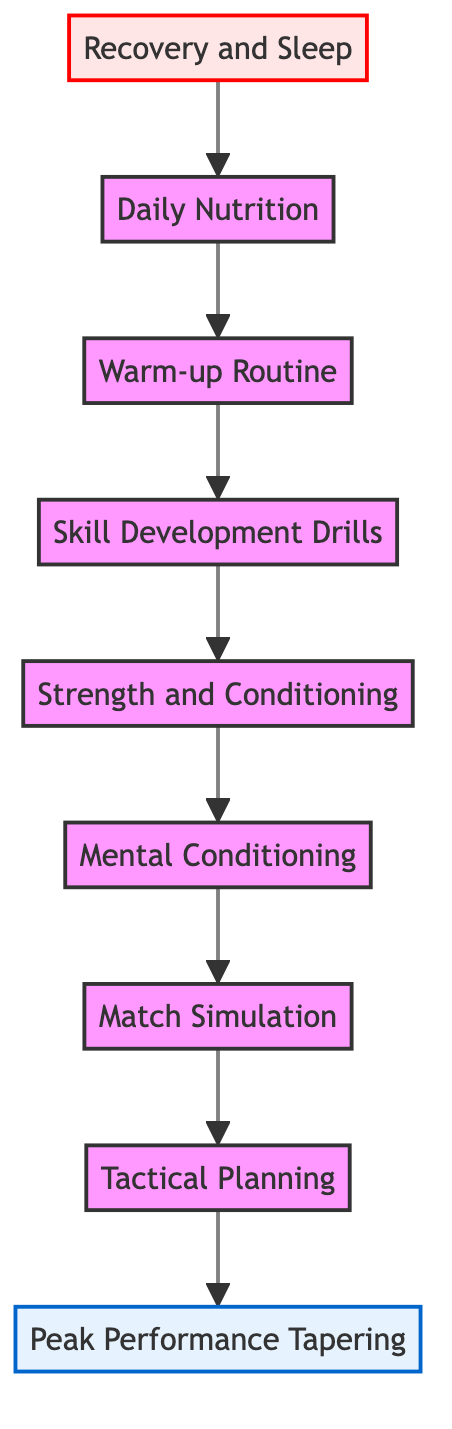What is the first step in the training preparation routine? The diagram starts at the bottom with "Recovery and Sleep" as the first step, indicating that it is the foundational element of the training preparation routine.
Answer: Recovery and Sleep Which step focuses on nutrition? The second step after "Recovery and Sleep" is "Daily Nutrition," which highlights its importance in fueling training and recovery.
Answer: Daily Nutrition How many nodes are in the diagram? Counting each distinct step from "Recovery and Sleep" to "Peak Performance Tapering," there are a total of nine nodes in the flowchart.
Answer: Nine What is the last step before reaching "Peak Performance Tapering"? The step leading directly to "Peak Performance Tapering" is "Tactical Planning," making it the penultimate step in the process.
Answer: Tactical Planning Which two steps are focused on mental readiness? The steps "Mental Conditioning" and "Visualization" both emphasize preparing the athlete mentally for performance.
Answer: Mental Conditioning, Visualization What is the relationship between "Skill Development Drills" and "Warm-up Routine"? "Warm-up Routine" precedes "Skill Development Drills" in the flow, indicating that warming up physically prepares the athlete for skill development.
Answer: Warm-up Routine precedes Skill Development Drills What are the last three steps in the training preparation routine? The last three steps listed at the top of the flowchart are "Match Simulation," "Tactical Planning," and "Peak Performance Tapering," indicating a progression toward peak performance during actual matches.
Answer: Match Simulation, Tactical Planning, Peak Performance Tapering What should be focused on after "Strength and Conditioning"? Following "Strength and Conditioning," the next focus is on "Mental Conditioning," suggesting that improving physical fitness should be complemented by mental training.
Answer: Mental Conditioning What types of activities are included in "Strength and Conditioning"? "Strength and Conditioning" involves gym workouts, resistance training, and plyometrics, which are designed to enhance physical strength and endurance.
Answer: Gym workouts, resistance training, plyometrics 